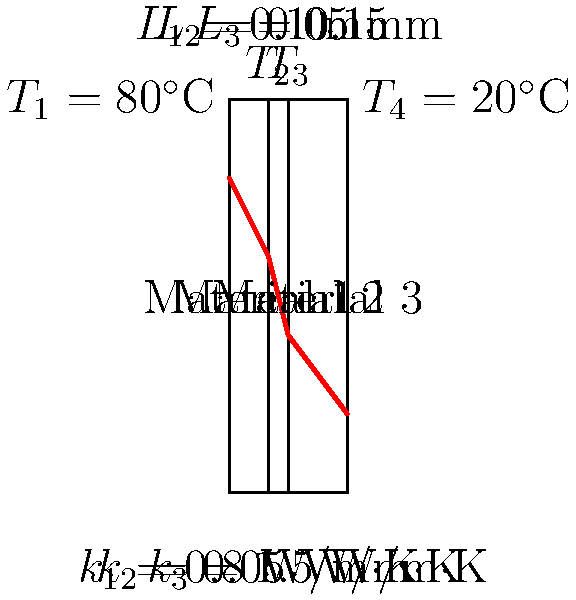Consider a composite wall consisting of three layers with different materials and thicknesses as shown in the figure. The temperatures at the outer surfaces are $T_1 = 80^\circ$C and $T_4 = 20^\circ$C. Given the thermal conductivities and thicknesses of each layer, calculate the heat flux through the wall and the temperature at the interface between Material 1 and Material 2 ($T_2$). To solve this problem, we'll follow these steps:

1) First, we need to calculate the total thermal resistance of the wall:
   $$R_{total} = \frac{L_1}{k_1} + \frac{L_2}{k_2} + \frac{L_3}{k_3}$$
   $$R_{total} = \frac{0.1}{0.8} + \frac{0.05}{0.05} + \frac{0.15}{1.5} = 0.125 + 1 + 0.1 = 1.225 \text{ m}^2\text{K}/\text{W}$$

2) Now we can calculate the heat flux using Fourier's law:
   $$q = \frac{T_1 - T_4}{R_{total}} = \frac{80 - 20}{1.225} = 49.0 \text{ W}/\text{m}^2$$

3) To find $T_2$, we can use the heat flux and the thermal resistance of the first layer:
   $$T_2 = T_1 - q \cdot \frac{L_1}{k_1}$$
   $$T_2 = 80 - 49.0 \cdot \frac{0.1}{0.8} = 73.9^\circ\text{C}$$

Therefore, the heat flux through the wall is 49.0 W/m², and the temperature at the interface between Material 1 and Material 2 (T₂) is 73.9°C.
Answer: Heat flux: 49.0 W/m²; T₂: 73.9°C 